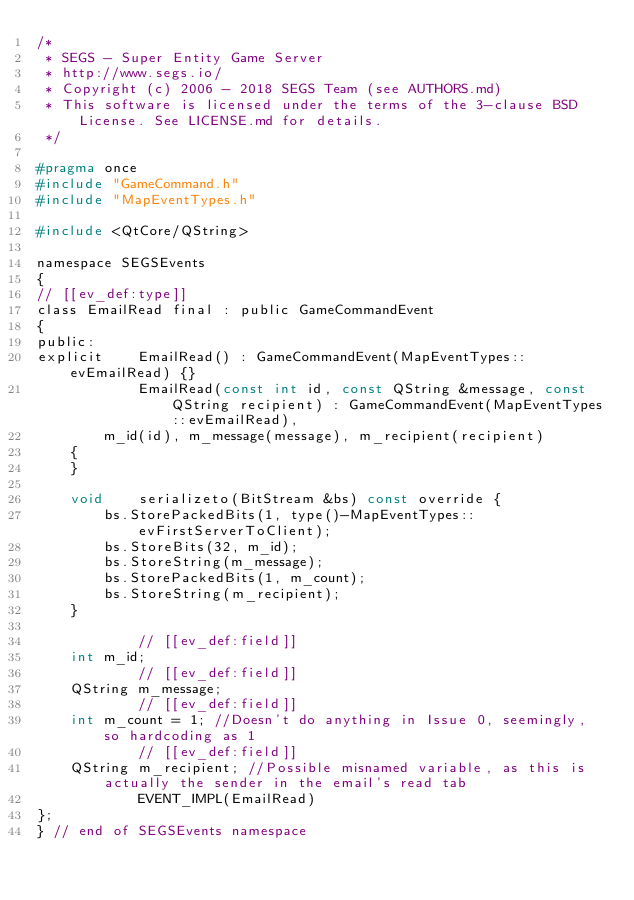Convert code to text. <code><loc_0><loc_0><loc_500><loc_500><_C_>/*
 * SEGS - Super Entity Game Server
 * http://www.segs.io/
 * Copyright (c) 2006 - 2018 SEGS Team (see AUTHORS.md)
 * This software is licensed under the terms of the 3-clause BSD License. See LICENSE.md for details.
 */

#pragma once
#include "GameCommand.h"
#include "MapEventTypes.h"

#include <QtCore/QString>

namespace SEGSEvents
{
// [[ev_def:type]]
class EmailRead final : public GameCommandEvent
{
public:
explicit    EmailRead() : GameCommandEvent(MapEventTypes::evEmailRead) {}
            EmailRead(const int id, const QString &message, const QString recipient) : GameCommandEvent(MapEventTypes::evEmailRead),
        m_id(id), m_message(message), m_recipient(recipient)
    {
    }

    void    serializeto(BitStream &bs) const override {
        bs.StorePackedBits(1, type()-MapEventTypes::evFirstServerToClient);
        bs.StoreBits(32, m_id);
        bs.StoreString(m_message);
        bs.StorePackedBits(1, m_count);
        bs.StoreString(m_recipient);
    }

            // [[ev_def:field]]
    int m_id;
            // [[ev_def:field]]
    QString m_message;
            // [[ev_def:field]]
    int m_count = 1; //Doesn't do anything in Issue 0, seemingly, so hardcoding as 1
            // [[ev_def:field]]
    QString m_recipient; //Possible misnamed variable, as this is actually the sender in the email's read tab
            EVENT_IMPL(EmailRead)
};
} // end of SEGSEvents namespace

</code> 